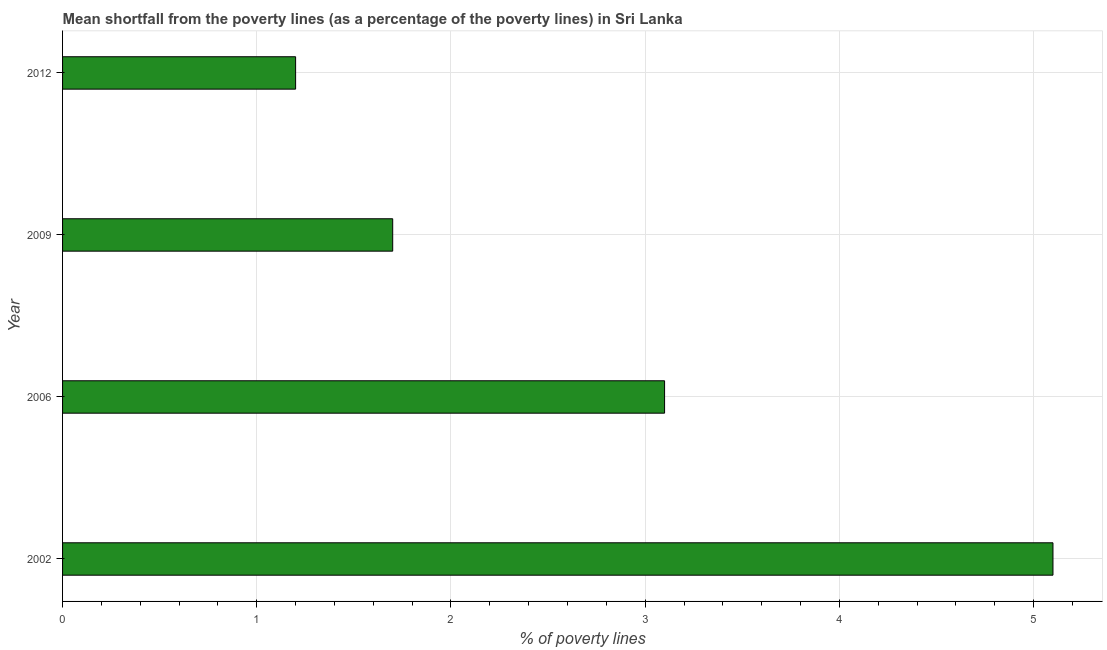Does the graph contain any zero values?
Ensure brevity in your answer.  No. Does the graph contain grids?
Ensure brevity in your answer.  Yes. What is the title of the graph?
Provide a succinct answer. Mean shortfall from the poverty lines (as a percentage of the poverty lines) in Sri Lanka. What is the label or title of the X-axis?
Ensure brevity in your answer.  % of poverty lines. What is the label or title of the Y-axis?
Your answer should be very brief. Year. What is the poverty gap at national poverty lines in 2006?
Offer a very short reply. 3.1. Across all years, what is the maximum poverty gap at national poverty lines?
Offer a very short reply. 5.1. What is the sum of the poverty gap at national poverty lines?
Your answer should be compact. 11.1. What is the average poverty gap at national poverty lines per year?
Offer a very short reply. 2.77. What is the median poverty gap at national poverty lines?
Ensure brevity in your answer.  2.4. In how many years, is the poverty gap at national poverty lines greater than 1.8 %?
Offer a terse response. 2. Do a majority of the years between 2009 and 2012 (inclusive) have poverty gap at national poverty lines greater than 3.4 %?
Provide a short and direct response. No. What is the ratio of the poverty gap at national poverty lines in 2006 to that in 2012?
Ensure brevity in your answer.  2.58. Is the poverty gap at national poverty lines in 2009 less than that in 2012?
Give a very brief answer. No. What is the difference between the highest and the second highest poverty gap at national poverty lines?
Your answer should be very brief. 2. In how many years, is the poverty gap at national poverty lines greater than the average poverty gap at national poverty lines taken over all years?
Provide a short and direct response. 2. How many bars are there?
Keep it short and to the point. 4. Are all the bars in the graph horizontal?
Make the answer very short. Yes. Are the values on the major ticks of X-axis written in scientific E-notation?
Make the answer very short. No. What is the % of poverty lines of 2002?
Offer a terse response. 5.1. What is the % of poverty lines of 2012?
Provide a short and direct response. 1.2. What is the difference between the % of poverty lines in 2006 and 2009?
Your answer should be compact. 1.4. What is the difference between the % of poverty lines in 2006 and 2012?
Keep it short and to the point. 1.9. What is the difference between the % of poverty lines in 2009 and 2012?
Offer a very short reply. 0.5. What is the ratio of the % of poverty lines in 2002 to that in 2006?
Ensure brevity in your answer.  1.65. What is the ratio of the % of poverty lines in 2002 to that in 2012?
Provide a short and direct response. 4.25. What is the ratio of the % of poverty lines in 2006 to that in 2009?
Make the answer very short. 1.82. What is the ratio of the % of poverty lines in 2006 to that in 2012?
Your answer should be very brief. 2.58. What is the ratio of the % of poverty lines in 2009 to that in 2012?
Give a very brief answer. 1.42. 